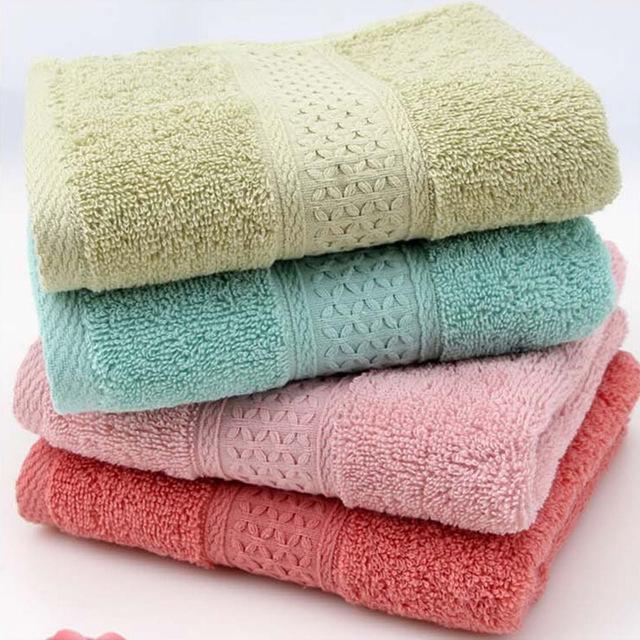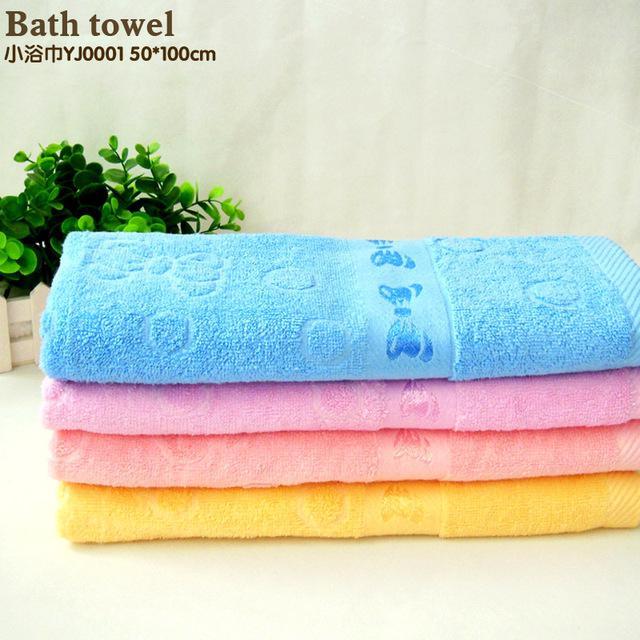The first image is the image on the left, the second image is the image on the right. Considering the images on both sides, is "The left and right image contains the same number of fold or rolled towels." valid? Answer yes or no. Yes. The first image is the image on the left, the second image is the image on the right. Considering the images on both sides, is "All towels shown are solid colored, and at least one image shows a vertical stack of four different colored folded towels." valid? Answer yes or no. Yes. 